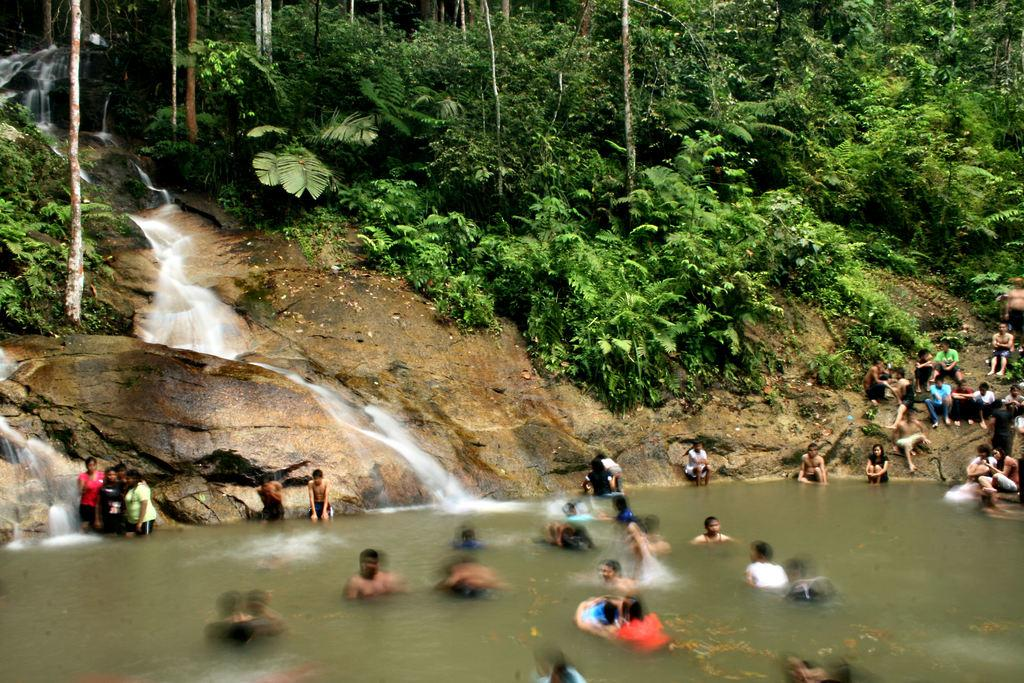What are the people in the image doing? There are many people in the water and people sitting on the ground in the image. What type of vegetation can be seen in the image? There are many trees and plants in the image. Is there any water visible in the image? Yes, there is a flow of water visible in the image. What type of collar can be seen on the flame in the image? There is no flame present in the image, and therefore no collar can be seen on it. 